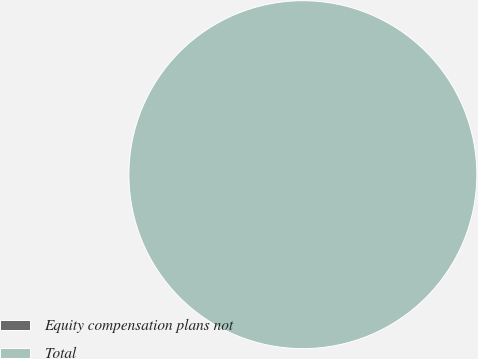Convert chart to OTSL. <chart><loc_0><loc_0><loc_500><loc_500><pie_chart><fcel>Equity compensation plans not<fcel>Total<nl><fcel>0.0%<fcel>100.0%<nl></chart> 